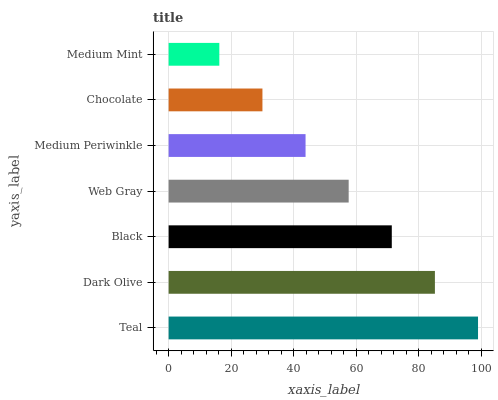Is Medium Mint the minimum?
Answer yes or no. Yes. Is Teal the maximum?
Answer yes or no. Yes. Is Dark Olive the minimum?
Answer yes or no. No. Is Dark Olive the maximum?
Answer yes or no. No. Is Teal greater than Dark Olive?
Answer yes or no. Yes. Is Dark Olive less than Teal?
Answer yes or no. Yes. Is Dark Olive greater than Teal?
Answer yes or no. No. Is Teal less than Dark Olive?
Answer yes or no. No. Is Web Gray the high median?
Answer yes or no. Yes. Is Web Gray the low median?
Answer yes or no. Yes. Is Medium Periwinkle the high median?
Answer yes or no. No. Is Black the low median?
Answer yes or no. No. 